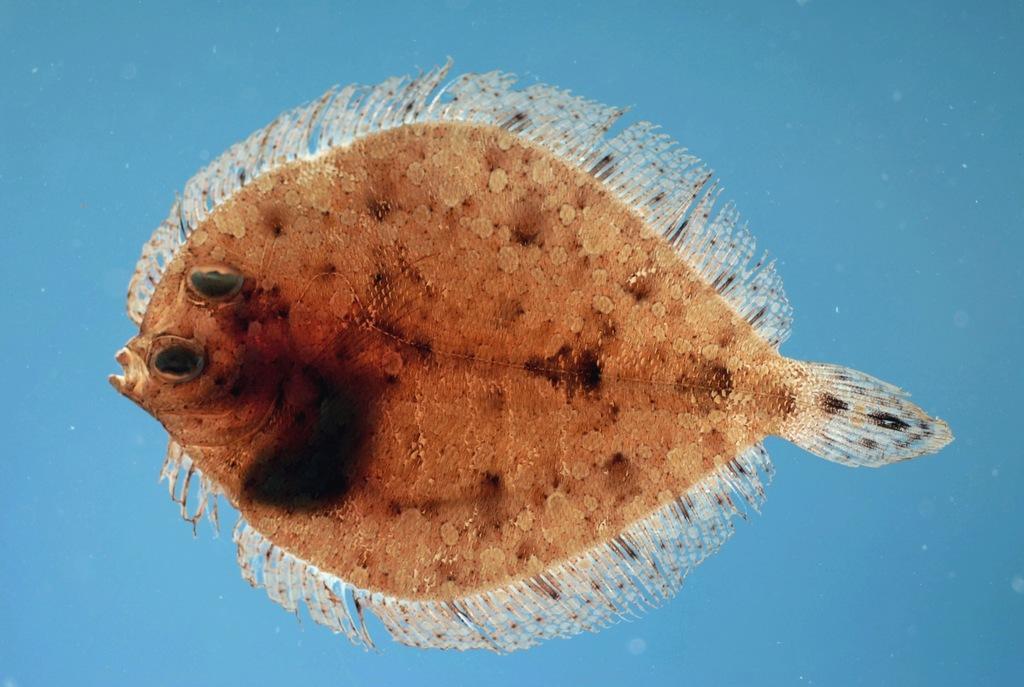Describe this image in one or two sentences. In this image I can see a fish which is in brown color and I can see blue color background. 